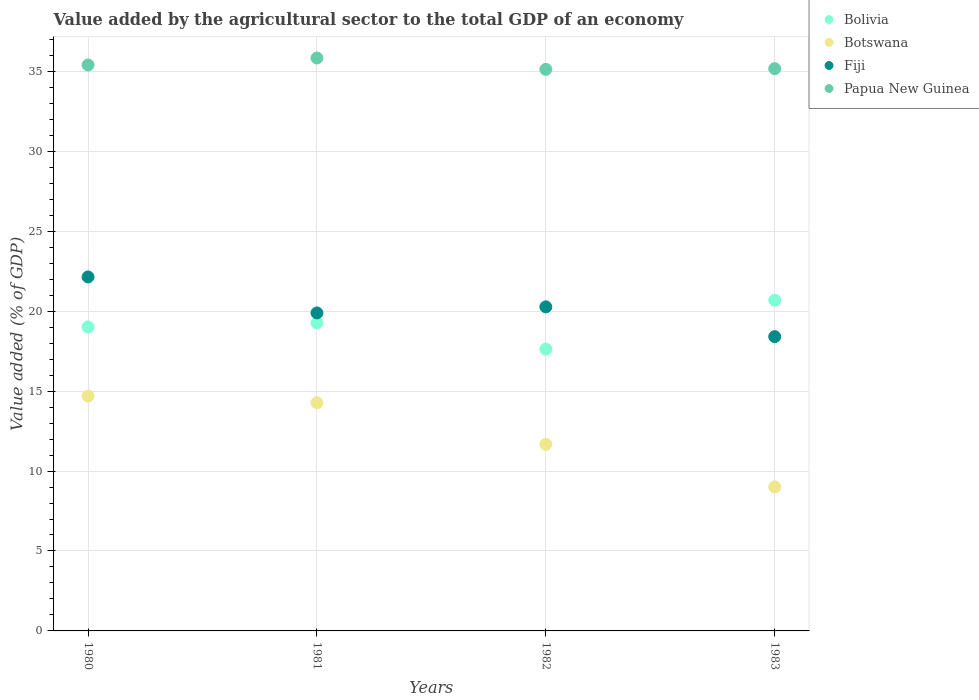What is the value added by the agricultural sector to the total GDP in Fiji in 1981?
Your answer should be compact. 19.89. Across all years, what is the maximum value added by the agricultural sector to the total GDP in Papua New Guinea?
Give a very brief answer. 35.84. Across all years, what is the minimum value added by the agricultural sector to the total GDP in Botswana?
Make the answer very short. 9.01. In which year was the value added by the agricultural sector to the total GDP in Fiji maximum?
Offer a very short reply. 1980. What is the total value added by the agricultural sector to the total GDP in Bolivia in the graph?
Your answer should be very brief. 76.6. What is the difference between the value added by the agricultural sector to the total GDP in Botswana in 1981 and that in 1983?
Give a very brief answer. 5.26. What is the difference between the value added by the agricultural sector to the total GDP in Papua New Guinea in 1980 and the value added by the agricultural sector to the total GDP in Bolivia in 1982?
Give a very brief answer. 17.77. What is the average value added by the agricultural sector to the total GDP in Botswana per year?
Your response must be concise. 12.41. In the year 1983, what is the difference between the value added by the agricultural sector to the total GDP in Fiji and value added by the agricultural sector to the total GDP in Bolivia?
Make the answer very short. -2.28. In how many years, is the value added by the agricultural sector to the total GDP in Fiji greater than 20 %?
Offer a terse response. 2. What is the ratio of the value added by the agricultural sector to the total GDP in Fiji in 1982 to that in 1983?
Your response must be concise. 1.1. What is the difference between the highest and the second highest value added by the agricultural sector to the total GDP in Fiji?
Keep it short and to the point. 1.87. What is the difference between the highest and the lowest value added by the agricultural sector to the total GDP in Papua New Guinea?
Keep it short and to the point. 0.71. In how many years, is the value added by the agricultural sector to the total GDP in Fiji greater than the average value added by the agricultural sector to the total GDP in Fiji taken over all years?
Give a very brief answer. 2. Is the sum of the value added by the agricultural sector to the total GDP in Fiji in 1980 and 1981 greater than the maximum value added by the agricultural sector to the total GDP in Papua New Guinea across all years?
Provide a short and direct response. Yes. Is it the case that in every year, the sum of the value added by the agricultural sector to the total GDP in Botswana and value added by the agricultural sector to the total GDP in Papua New Guinea  is greater than the sum of value added by the agricultural sector to the total GDP in Fiji and value added by the agricultural sector to the total GDP in Bolivia?
Offer a terse response. Yes. Is the value added by the agricultural sector to the total GDP in Bolivia strictly greater than the value added by the agricultural sector to the total GDP in Botswana over the years?
Your answer should be very brief. Yes. How many years are there in the graph?
Provide a short and direct response. 4. Are the values on the major ticks of Y-axis written in scientific E-notation?
Your answer should be very brief. No. How many legend labels are there?
Offer a very short reply. 4. What is the title of the graph?
Provide a short and direct response. Value added by the agricultural sector to the total GDP of an economy. Does "Colombia" appear as one of the legend labels in the graph?
Provide a succinct answer. No. What is the label or title of the Y-axis?
Provide a short and direct response. Value added (% of GDP). What is the Value added (% of GDP) in Bolivia in 1980?
Ensure brevity in your answer.  19.02. What is the Value added (% of GDP) of Botswana in 1980?
Your response must be concise. 14.69. What is the Value added (% of GDP) of Fiji in 1980?
Your answer should be compact. 22.14. What is the Value added (% of GDP) of Papua New Guinea in 1980?
Your answer should be very brief. 35.4. What is the Value added (% of GDP) of Bolivia in 1981?
Offer a terse response. 19.27. What is the Value added (% of GDP) of Botswana in 1981?
Offer a very short reply. 14.27. What is the Value added (% of GDP) of Fiji in 1981?
Your answer should be compact. 19.89. What is the Value added (% of GDP) of Papua New Guinea in 1981?
Keep it short and to the point. 35.84. What is the Value added (% of GDP) in Bolivia in 1982?
Offer a terse response. 17.63. What is the Value added (% of GDP) of Botswana in 1982?
Your response must be concise. 11.67. What is the Value added (% of GDP) of Fiji in 1982?
Provide a short and direct response. 20.27. What is the Value added (% of GDP) of Papua New Guinea in 1982?
Offer a very short reply. 35.13. What is the Value added (% of GDP) in Bolivia in 1983?
Provide a succinct answer. 20.69. What is the Value added (% of GDP) of Botswana in 1983?
Keep it short and to the point. 9.01. What is the Value added (% of GDP) in Fiji in 1983?
Ensure brevity in your answer.  18.41. What is the Value added (% of GDP) of Papua New Guinea in 1983?
Keep it short and to the point. 35.17. Across all years, what is the maximum Value added (% of GDP) in Bolivia?
Your response must be concise. 20.69. Across all years, what is the maximum Value added (% of GDP) of Botswana?
Your answer should be compact. 14.69. Across all years, what is the maximum Value added (% of GDP) of Fiji?
Make the answer very short. 22.14. Across all years, what is the maximum Value added (% of GDP) of Papua New Guinea?
Offer a terse response. 35.84. Across all years, what is the minimum Value added (% of GDP) of Bolivia?
Keep it short and to the point. 17.63. Across all years, what is the minimum Value added (% of GDP) of Botswana?
Your answer should be compact. 9.01. Across all years, what is the minimum Value added (% of GDP) in Fiji?
Ensure brevity in your answer.  18.41. Across all years, what is the minimum Value added (% of GDP) of Papua New Guinea?
Provide a succinct answer. 35.13. What is the total Value added (% of GDP) of Bolivia in the graph?
Your answer should be compact. 76.6. What is the total Value added (% of GDP) in Botswana in the graph?
Offer a very short reply. 49.64. What is the total Value added (% of GDP) in Fiji in the graph?
Provide a succinct answer. 80.71. What is the total Value added (% of GDP) of Papua New Guinea in the graph?
Your answer should be very brief. 141.53. What is the difference between the Value added (% of GDP) of Bolivia in 1980 and that in 1981?
Your response must be concise. -0.25. What is the difference between the Value added (% of GDP) in Botswana in 1980 and that in 1981?
Keep it short and to the point. 0.41. What is the difference between the Value added (% of GDP) in Fiji in 1980 and that in 1981?
Offer a terse response. 2.25. What is the difference between the Value added (% of GDP) in Papua New Guinea in 1980 and that in 1981?
Keep it short and to the point. -0.44. What is the difference between the Value added (% of GDP) in Bolivia in 1980 and that in 1982?
Keep it short and to the point. 1.39. What is the difference between the Value added (% of GDP) of Botswana in 1980 and that in 1982?
Give a very brief answer. 3.01. What is the difference between the Value added (% of GDP) in Fiji in 1980 and that in 1982?
Provide a succinct answer. 1.87. What is the difference between the Value added (% of GDP) of Papua New Guinea in 1980 and that in 1982?
Provide a short and direct response. 0.27. What is the difference between the Value added (% of GDP) in Bolivia in 1980 and that in 1983?
Your answer should be very brief. -1.67. What is the difference between the Value added (% of GDP) of Botswana in 1980 and that in 1983?
Provide a short and direct response. 5.67. What is the difference between the Value added (% of GDP) in Fiji in 1980 and that in 1983?
Offer a terse response. 3.74. What is the difference between the Value added (% of GDP) of Papua New Guinea in 1980 and that in 1983?
Provide a short and direct response. 0.23. What is the difference between the Value added (% of GDP) in Bolivia in 1981 and that in 1982?
Provide a succinct answer. 1.64. What is the difference between the Value added (% of GDP) of Botswana in 1981 and that in 1982?
Keep it short and to the point. 2.6. What is the difference between the Value added (% of GDP) in Fiji in 1981 and that in 1982?
Offer a terse response. -0.38. What is the difference between the Value added (% of GDP) in Papua New Guinea in 1981 and that in 1982?
Your answer should be compact. 0.71. What is the difference between the Value added (% of GDP) of Bolivia in 1981 and that in 1983?
Offer a terse response. -1.42. What is the difference between the Value added (% of GDP) in Botswana in 1981 and that in 1983?
Offer a very short reply. 5.26. What is the difference between the Value added (% of GDP) of Fiji in 1981 and that in 1983?
Your answer should be compact. 1.48. What is the difference between the Value added (% of GDP) of Papua New Guinea in 1981 and that in 1983?
Your answer should be very brief. 0.67. What is the difference between the Value added (% of GDP) in Bolivia in 1982 and that in 1983?
Your response must be concise. -3.06. What is the difference between the Value added (% of GDP) in Botswana in 1982 and that in 1983?
Your answer should be compact. 2.66. What is the difference between the Value added (% of GDP) in Fiji in 1982 and that in 1983?
Ensure brevity in your answer.  1.86. What is the difference between the Value added (% of GDP) in Papua New Guinea in 1982 and that in 1983?
Your response must be concise. -0.05. What is the difference between the Value added (% of GDP) in Bolivia in 1980 and the Value added (% of GDP) in Botswana in 1981?
Your answer should be compact. 4.74. What is the difference between the Value added (% of GDP) of Bolivia in 1980 and the Value added (% of GDP) of Fiji in 1981?
Ensure brevity in your answer.  -0.87. What is the difference between the Value added (% of GDP) in Bolivia in 1980 and the Value added (% of GDP) in Papua New Guinea in 1981?
Give a very brief answer. -16.82. What is the difference between the Value added (% of GDP) in Botswana in 1980 and the Value added (% of GDP) in Fiji in 1981?
Provide a short and direct response. -5.2. What is the difference between the Value added (% of GDP) in Botswana in 1980 and the Value added (% of GDP) in Papua New Guinea in 1981?
Offer a very short reply. -21.15. What is the difference between the Value added (% of GDP) of Fiji in 1980 and the Value added (% of GDP) of Papua New Guinea in 1981?
Give a very brief answer. -13.69. What is the difference between the Value added (% of GDP) of Bolivia in 1980 and the Value added (% of GDP) of Botswana in 1982?
Your response must be concise. 7.34. What is the difference between the Value added (% of GDP) of Bolivia in 1980 and the Value added (% of GDP) of Fiji in 1982?
Provide a succinct answer. -1.25. What is the difference between the Value added (% of GDP) of Bolivia in 1980 and the Value added (% of GDP) of Papua New Guinea in 1982?
Ensure brevity in your answer.  -16.11. What is the difference between the Value added (% of GDP) in Botswana in 1980 and the Value added (% of GDP) in Fiji in 1982?
Your answer should be compact. -5.58. What is the difference between the Value added (% of GDP) in Botswana in 1980 and the Value added (% of GDP) in Papua New Guinea in 1982?
Offer a very short reply. -20.44. What is the difference between the Value added (% of GDP) in Fiji in 1980 and the Value added (% of GDP) in Papua New Guinea in 1982?
Keep it short and to the point. -12.98. What is the difference between the Value added (% of GDP) in Bolivia in 1980 and the Value added (% of GDP) in Botswana in 1983?
Give a very brief answer. 10. What is the difference between the Value added (% of GDP) in Bolivia in 1980 and the Value added (% of GDP) in Fiji in 1983?
Ensure brevity in your answer.  0.61. What is the difference between the Value added (% of GDP) of Bolivia in 1980 and the Value added (% of GDP) of Papua New Guinea in 1983?
Keep it short and to the point. -16.15. What is the difference between the Value added (% of GDP) in Botswana in 1980 and the Value added (% of GDP) in Fiji in 1983?
Provide a succinct answer. -3.72. What is the difference between the Value added (% of GDP) of Botswana in 1980 and the Value added (% of GDP) of Papua New Guinea in 1983?
Make the answer very short. -20.48. What is the difference between the Value added (% of GDP) of Fiji in 1980 and the Value added (% of GDP) of Papua New Guinea in 1983?
Ensure brevity in your answer.  -13.03. What is the difference between the Value added (% of GDP) of Bolivia in 1981 and the Value added (% of GDP) of Botswana in 1982?
Ensure brevity in your answer.  7.6. What is the difference between the Value added (% of GDP) in Bolivia in 1981 and the Value added (% of GDP) in Fiji in 1982?
Offer a terse response. -1. What is the difference between the Value added (% of GDP) in Bolivia in 1981 and the Value added (% of GDP) in Papua New Guinea in 1982?
Ensure brevity in your answer.  -15.85. What is the difference between the Value added (% of GDP) in Botswana in 1981 and the Value added (% of GDP) in Fiji in 1982?
Ensure brevity in your answer.  -6. What is the difference between the Value added (% of GDP) of Botswana in 1981 and the Value added (% of GDP) of Papua New Guinea in 1982?
Provide a short and direct response. -20.85. What is the difference between the Value added (% of GDP) of Fiji in 1981 and the Value added (% of GDP) of Papua New Guinea in 1982?
Give a very brief answer. -15.23. What is the difference between the Value added (% of GDP) in Bolivia in 1981 and the Value added (% of GDP) in Botswana in 1983?
Make the answer very short. 10.26. What is the difference between the Value added (% of GDP) in Bolivia in 1981 and the Value added (% of GDP) in Fiji in 1983?
Your answer should be compact. 0.86. What is the difference between the Value added (% of GDP) in Bolivia in 1981 and the Value added (% of GDP) in Papua New Guinea in 1983?
Your response must be concise. -15.9. What is the difference between the Value added (% of GDP) in Botswana in 1981 and the Value added (% of GDP) in Fiji in 1983?
Offer a terse response. -4.13. What is the difference between the Value added (% of GDP) in Botswana in 1981 and the Value added (% of GDP) in Papua New Guinea in 1983?
Keep it short and to the point. -20.9. What is the difference between the Value added (% of GDP) in Fiji in 1981 and the Value added (% of GDP) in Papua New Guinea in 1983?
Your answer should be compact. -15.28. What is the difference between the Value added (% of GDP) in Bolivia in 1982 and the Value added (% of GDP) in Botswana in 1983?
Make the answer very short. 8.61. What is the difference between the Value added (% of GDP) of Bolivia in 1982 and the Value added (% of GDP) of Fiji in 1983?
Keep it short and to the point. -0.78. What is the difference between the Value added (% of GDP) of Bolivia in 1982 and the Value added (% of GDP) of Papua New Guinea in 1983?
Ensure brevity in your answer.  -17.54. What is the difference between the Value added (% of GDP) of Botswana in 1982 and the Value added (% of GDP) of Fiji in 1983?
Your answer should be compact. -6.73. What is the difference between the Value added (% of GDP) of Botswana in 1982 and the Value added (% of GDP) of Papua New Guinea in 1983?
Your answer should be very brief. -23.5. What is the difference between the Value added (% of GDP) of Fiji in 1982 and the Value added (% of GDP) of Papua New Guinea in 1983?
Keep it short and to the point. -14.9. What is the average Value added (% of GDP) in Bolivia per year?
Ensure brevity in your answer.  19.15. What is the average Value added (% of GDP) of Botswana per year?
Give a very brief answer. 12.41. What is the average Value added (% of GDP) in Fiji per year?
Offer a very short reply. 20.18. What is the average Value added (% of GDP) in Papua New Guinea per year?
Your response must be concise. 35.38. In the year 1980, what is the difference between the Value added (% of GDP) of Bolivia and Value added (% of GDP) of Botswana?
Your response must be concise. 4.33. In the year 1980, what is the difference between the Value added (% of GDP) of Bolivia and Value added (% of GDP) of Fiji?
Give a very brief answer. -3.13. In the year 1980, what is the difference between the Value added (% of GDP) of Bolivia and Value added (% of GDP) of Papua New Guinea?
Give a very brief answer. -16.38. In the year 1980, what is the difference between the Value added (% of GDP) of Botswana and Value added (% of GDP) of Fiji?
Provide a short and direct response. -7.46. In the year 1980, what is the difference between the Value added (% of GDP) in Botswana and Value added (% of GDP) in Papua New Guinea?
Ensure brevity in your answer.  -20.71. In the year 1980, what is the difference between the Value added (% of GDP) in Fiji and Value added (% of GDP) in Papua New Guinea?
Provide a short and direct response. -13.26. In the year 1981, what is the difference between the Value added (% of GDP) of Bolivia and Value added (% of GDP) of Botswana?
Offer a terse response. 5. In the year 1981, what is the difference between the Value added (% of GDP) in Bolivia and Value added (% of GDP) in Fiji?
Offer a terse response. -0.62. In the year 1981, what is the difference between the Value added (% of GDP) of Bolivia and Value added (% of GDP) of Papua New Guinea?
Offer a very short reply. -16.56. In the year 1981, what is the difference between the Value added (% of GDP) of Botswana and Value added (% of GDP) of Fiji?
Offer a terse response. -5.62. In the year 1981, what is the difference between the Value added (% of GDP) in Botswana and Value added (% of GDP) in Papua New Guinea?
Make the answer very short. -21.56. In the year 1981, what is the difference between the Value added (% of GDP) in Fiji and Value added (% of GDP) in Papua New Guinea?
Provide a short and direct response. -15.94. In the year 1982, what is the difference between the Value added (% of GDP) of Bolivia and Value added (% of GDP) of Botswana?
Keep it short and to the point. 5.95. In the year 1982, what is the difference between the Value added (% of GDP) in Bolivia and Value added (% of GDP) in Fiji?
Your response must be concise. -2.64. In the year 1982, what is the difference between the Value added (% of GDP) in Bolivia and Value added (% of GDP) in Papua New Guinea?
Ensure brevity in your answer.  -17.5. In the year 1982, what is the difference between the Value added (% of GDP) of Botswana and Value added (% of GDP) of Fiji?
Your response must be concise. -8.6. In the year 1982, what is the difference between the Value added (% of GDP) of Botswana and Value added (% of GDP) of Papua New Guinea?
Ensure brevity in your answer.  -23.45. In the year 1982, what is the difference between the Value added (% of GDP) of Fiji and Value added (% of GDP) of Papua New Guinea?
Provide a short and direct response. -14.86. In the year 1983, what is the difference between the Value added (% of GDP) in Bolivia and Value added (% of GDP) in Botswana?
Provide a succinct answer. 11.68. In the year 1983, what is the difference between the Value added (% of GDP) in Bolivia and Value added (% of GDP) in Fiji?
Offer a terse response. 2.28. In the year 1983, what is the difference between the Value added (% of GDP) of Bolivia and Value added (% of GDP) of Papua New Guinea?
Provide a succinct answer. -14.48. In the year 1983, what is the difference between the Value added (% of GDP) in Botswana and Value added (% of GDP) in Fiji?
Give a very brief answer. -9.39. In the year 1983, what is the difference between the Value added (% of GDP) of Botswana and Value added (% of GDP) of Papua New Guinea?
Provide a succinct answer. -26.16. In the year 1983, what is the difference between the Value added (% of GDP) of Fiji and Value added (% of GDP) of Papua New Guinea?
Make the answer very short. -16.76. What is the ratio of the Value added (% of GDP) of Bolivia in 1980 to that in 1981?
Offer a terse response. 0.99. What is the ratio of the Value added (% of GDP) in Botswana in 1980 to that in 1981?
Provide a short and direct response. 1.03. What is the ratio of the Value added (% of GDP) of Fiji in 1980 to that in 1981?
Your response must be concise. 1.11. What is the ratio of the Value added (% of GDP) of Papua New Guinea in 1980 to that in 1981?
Offer a very short reply. 0.99. What is the ratio of the Value added (% of GDP) in Bolivia in 1980 to that in 1982?
Your response must be concise. 1.08. What is the ratio of the Value added (% of GDP) of Botswana in 1980 to that in 1982?
Your answer should be compact. 1.26. What is the ratio of the Value added (% of GDP) in Fiji in 1980 to that in 1982?
Provide a succinct answer. 1.09. What is the ratio of the Value added (% of GDP) of Bolivia in 1980 to that in 1983?
Ensure brevity in your answer.  0.92. What is the ratio of the Value added (% of GDP) of Botswana in 1980 to that in 1983?
Provide a succinct answer. 1.63. What is the ratio of the Value added (% of GDP) in Fiji in 1980 to that in 1983?
Provide a short and direct response. 1.2. What is the ratio of the Value added (% of GDP) of Bolivia in 1981 to that in 1982?
Provide a succinct answer. 1.09. What is the ratio of the Value added (% of GDP) in Botswana in 1981 to that in 1982?
Give a very brief answer. 1.22. What is the ratio of the Value added (% of GDP) of Fiji in 1981 to that in 1982?
Keep it short and to the point. 0.98. What is the ratio of the Value added (% of GDP) of Papua New Guinea in 1981 to that in 1982?
Your response must be concise. 1.02. What is the ratio of the Value added (% of GDP) of Bolivia in 1981 to that in 1983?
Offer a very short reply. 0.93. What is the ratio of the Value added (% of GDP) in Botswana in 1981 to that in 1983?
Offer a terse response. 1.58. What is the ratio of the Value added (% of GDP) of Fiji in 1981 to that in 1983?
Offer a terse response. 1.08. What is the ratio of the Value added (% of GDP) of Papua New Guinea in 1981 to that in 1983?
Give a very brief answer. 1.02. What is the ratio of the Value added (% of GDP) of Bolivia in 1982 to that in 1983?
Provide a succinct answer. 0.85. What is the ratio of the Value added (% of GDP) of Botswana in 1982 to that in 1983?
Your answer should be very brief. 1.3. What is the ratio of the Value added (% of GDP) in Fiji in 1982 to that in 1983?
Your answer should be very brief. 1.1. What is the difference between the highest and the second highest Value added (% of GDP) in Bolivia?
Your answer should be compact. 1.42. What is the difference between the highest and the second highest Value added (% of GDP) in Botswana?
Give a very brief answer. 0.41. What is the difference between the highest and the second highest Value added (% of GDP) in Fiji?
Keep it short and to the point. 1.87. What is the difference between the highest and the second highest Value added (% of GDP) in Papua New Guinea?
Your answer should be very brief. 0.44. What is the difference between the highest and the lowest Value added (% of GDP) in Bolivia?
Offer a terse response. 3.06. What is the difference between the highest and the lowest Value added (% of GDP) of Botswana?
Offer a very short reply. 5.67. What is the difference between the highest and the lowest Value added (% of GDP) of Fiji?
Keep it short and to the point. 3.74. What is the difference between the highest and the lowest Value added (% of GDP) of Papua New Guinea?
Provide a short and direct response. 0.71. 